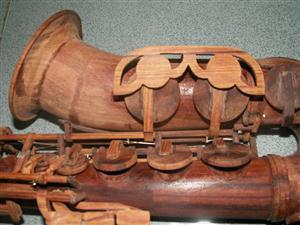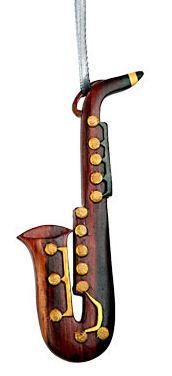The first image is the image on the left, the second image is the image on the right. Examine the images to the left and right. Is the description "One of the instruments has a plain white background." accurate? Answer yes or no. Yes. 